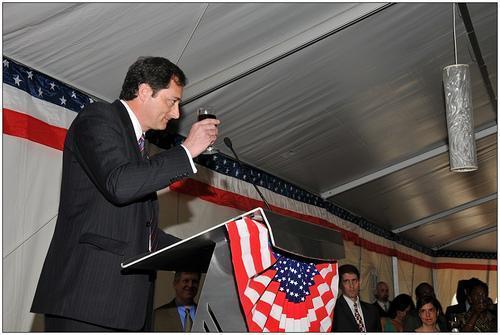How many people are there?
Give a very brief answer. 2. How many cats with spots do you see?
Give a very brief answer. 0. 